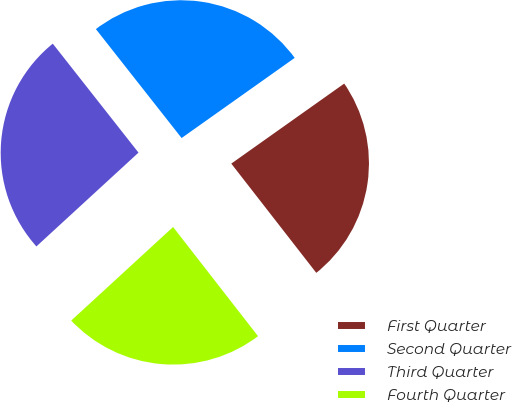Convert chart to OTSL. <chart><loc_0><loc_0><loc_500><loc_500><pie_chart><fcel>First Quarter<fcel>Second Quarter<fcel>Third Quarter<fcel>Fourth Quarter<nl><fcel>24.29%<fcel>25.8%<fcel>26.22%<fcel>23.7%<nl></chart> 